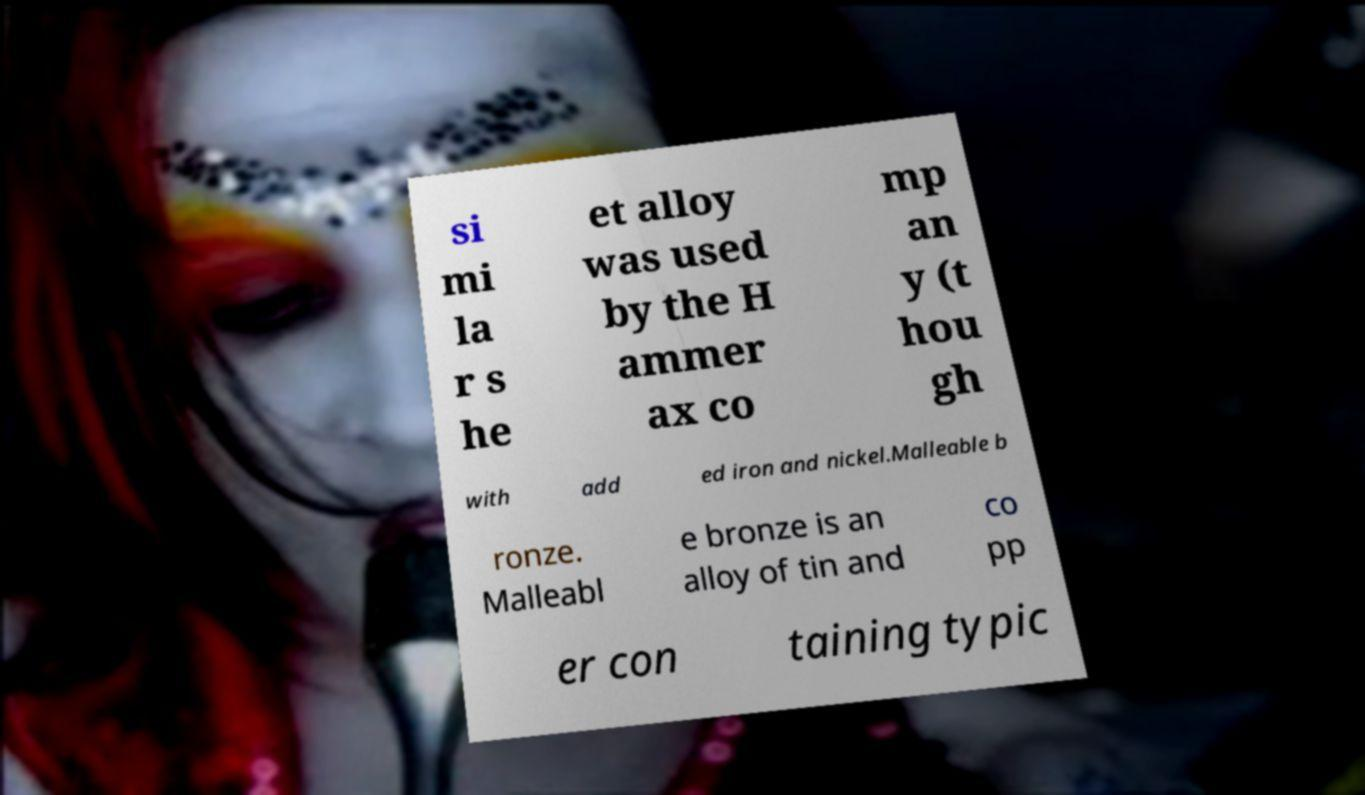There's text embedded in this image that I need extracted. Can you transcribe it verbatim? si mi la r s he et alloy was used by the H ammer ax co mp an y (t hou gh with add ed iron and nickel.Malleable b ronze. Malleabl e bronze is an alloy of tin and co pp er con taining typic 